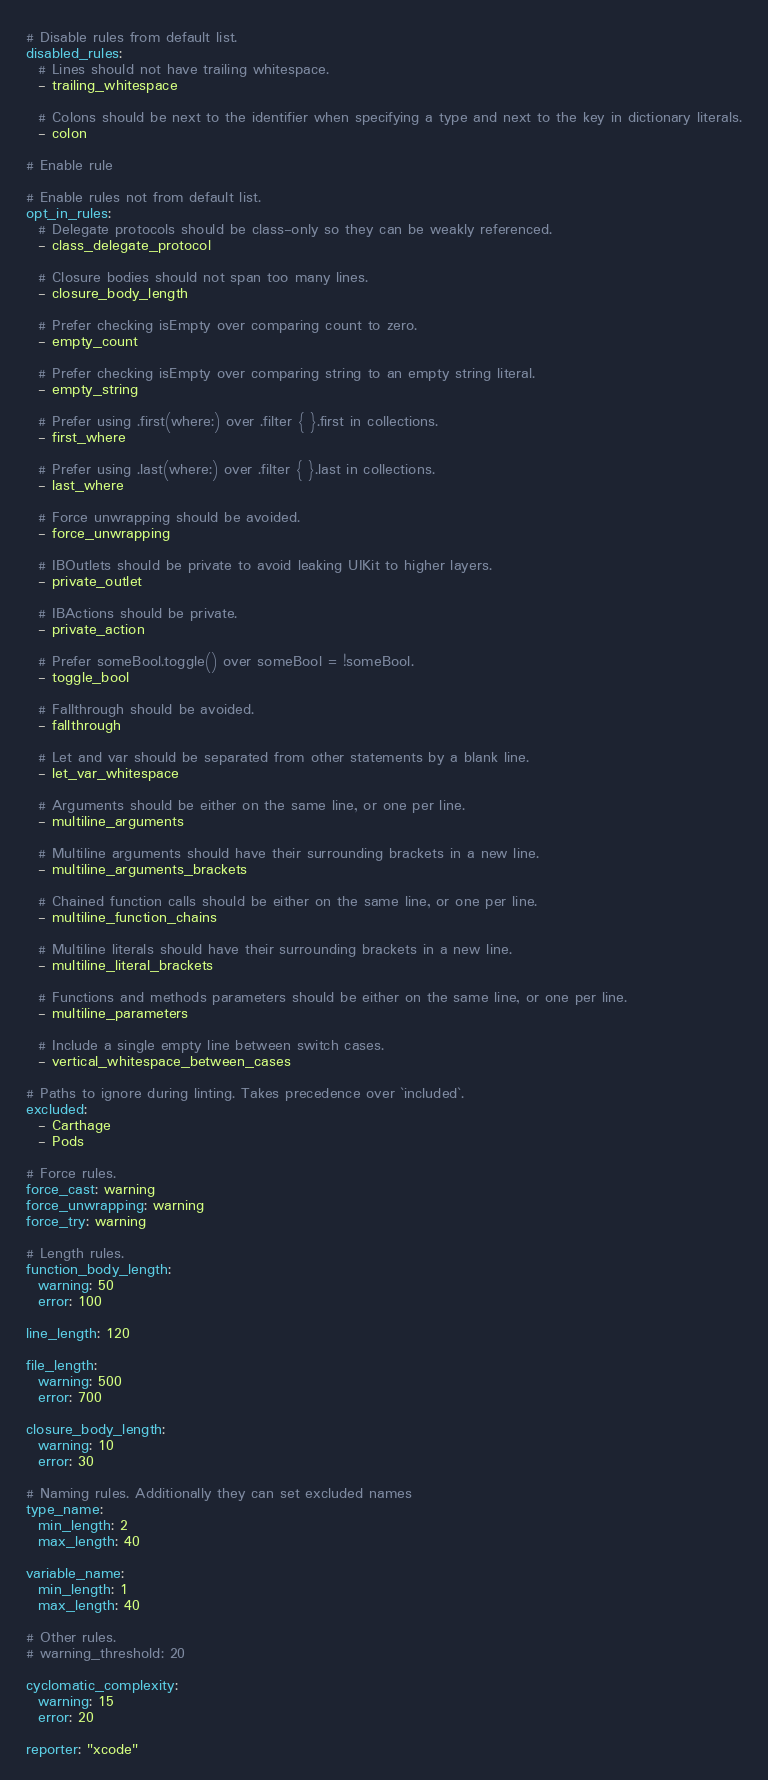Convert code to text. <code><loc_0><loc_0><loc_500><loc_500><_YAML_># Disable rules from default list.
disabled_rules:
  # Lines should not have trailing whitespace.
  - trailing_whitespace

  # Colons should be next to the identifier when specifying a type and next to the key in dictionary literals.
  - colon

# Enable rule

# Enable rules not from default list.
opt_in_rules:
  # Delegate protocols should be class-only so they can be weakly referenced.
  - class_delegate_protocol

  # Closure bodies should not span too many lines.
  - closure_body_length

  # Prefer checking isEmpty over comparing count to zero.
  - empty_count

  # Prefer checking isEmpty over comparing string to an empty string literal.
  - empty_string

  # Prefer using .first(where:) over .filter { }.first in collections.
  - first_where

  # Prefer using .last(where:) over .filter { }.last in collections.
  - last_where

  # Force unwrapping should be avoided.
  - force_unwrapping

  # IBOutlets should be private to avoid leaking UIKit to higher layers.
  - private_outlet

  # IBActions should be private.
  - private_action

  # Prefer someBool.toggle() over someBool = !someBool.
  - toggle_bool

  # Fallthrough should be avoided.
  - fallthrough

  # Let and var should be separated from other statements by a blank line.
  - let_var_whitespace

  # Arguments should be either on the same line, or one per line.
  - multiline_arguments

  # Multiline arguments should have their surrounding brackets in a new line.
  - multiline_arguments_brackets

  # Chained function calls should be either on the same line, or one per line.
  - multiline_function_chains

  # Multiline literals should have their surrounding brackets in a new line.
  - multiline_literal_brackets

  # Functions and methods parameters should be either on the same line, or one per line.
  - multiline_parameters

  # Include a single empty line between switch cases.
  - vertical_whitespace_between_cases

# Paths to ignore during linting. Takes precedence over `included`.
excluded:
  - Carthage
  - Pods

# Force rules.
force_cast: warning
force_unwrapping: warning
force_try: warning

# Length rules.
function_body_length:
  warning: 50
  error: 100

line_length: 120 

file_length:
  warning: 500
  error: 700

closure_body_length:
  warning: 10
  error: 30

# Naming rules. Additionally they can set excluded names
type_name:
  min_length: 2
  max_length: 40

variable_name:
  min_length: 1
  max_length: 40

# Other rules.
# warning_threshold: 20

cyclomatic_complexity:
  warning: 15
  error: 20

reporter: "xcode"
</code> 